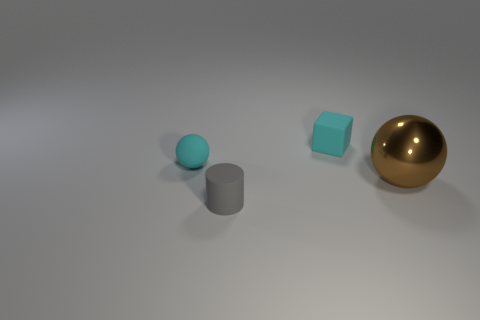Subtract all red balls. Subtract all red cubes. How many balls are left? 2 Add 4 cylinders. How many objects exist? 8 Subtract all cubes. How many objects are left? 3 Add 4 tiny spheres. How many tiny spheres exist? 5 Subtract 0 brown cylinders. How many objects are left? 4 Subtract all tiny rubber objects. Subtract all brown metal spheres. How many objects are left? 0 Add 4 matte things. How many matte things are left? 7 